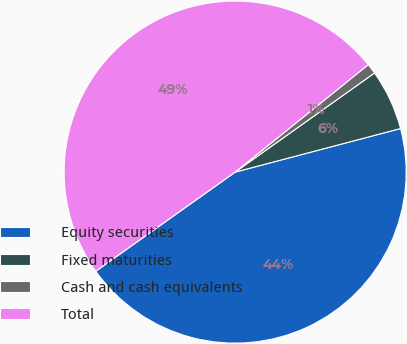Convert chart to OTSL. <chart><loc_0><loc_0><loc_500><loc_500><pie_chart><fcel>Equity securities<fcel>Fixed maturities<fcel>Cash and cash equivalents<fcel>Total<nl><fcel>44.26%<fcel>5.74%<fcel>0.97%<fcel>49.03%<nl></chart> 